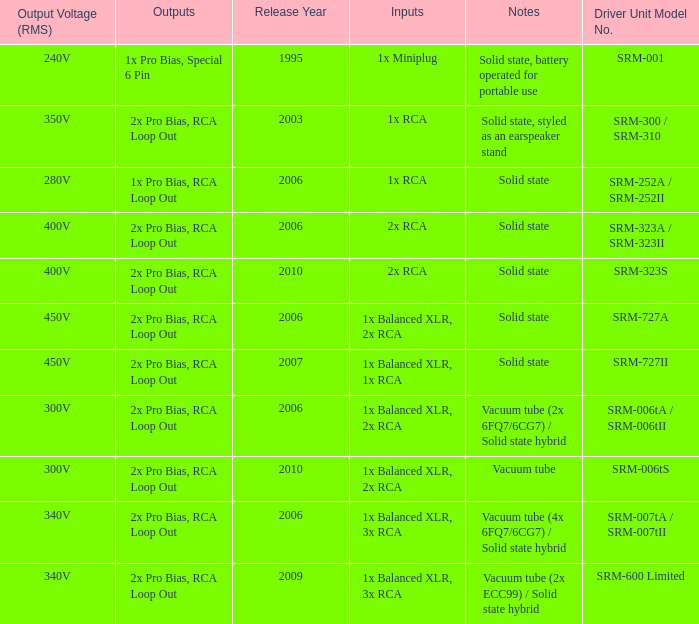How many outputs are there for solid state, battery operated for portable use listed in notes? 1.0. 